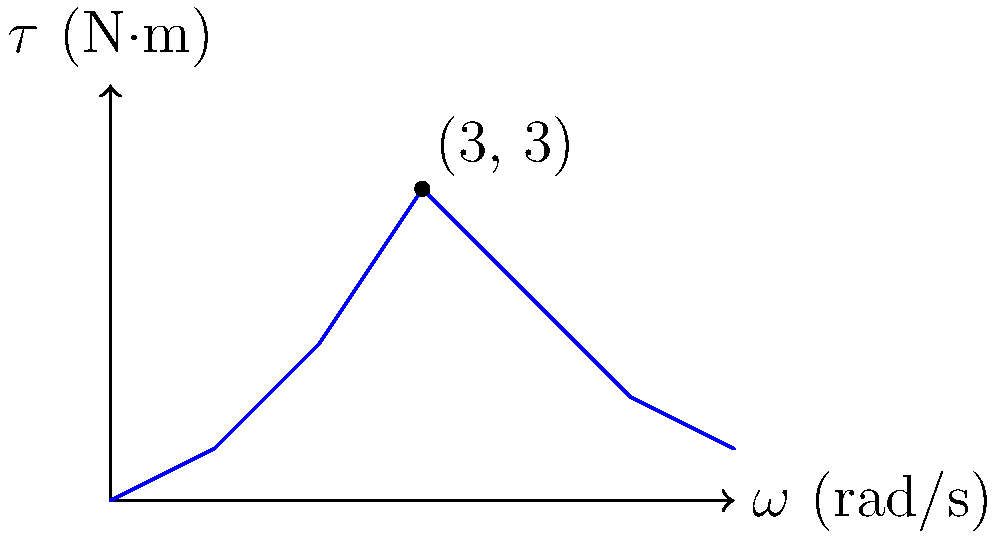A rotating shaft experiences a varying torque ($\tau$) over time, as shown in the graph. The shaft has a moment of inertia of 2 kg·m². At t = 3 seconds, the torque reaches its maximum value of 3 N·m. Calculate the angular acceleration ($\alpha$) of the shaft at this instant. To solve this problem, we'll use the rotational form of Newton's Second Law:

$$\tau = I\alpha$$

Where:
- $\tau$ is the torque
- $I$ is the moment of inertia
- $\alpha$ is the angular acceleration

We are given:
- $\tau = 3$ N·m (at t = 3 seconds)
- $I = 2$ kg·m²

Step 1: Rearrange the equation to solve for $\alpha$:
$$\alpha = \frac{\tau}{I}$$

Step 2: Substitute the known values:
$$\alpha = \frac{3 \text{ N·m}}{2 \text{ kg·m²}}$$

Step 3: Calculate the result:
$$\alpha = 1.5 \text{ rad/s²}$$

Therefore, the angular acceleration of the shaft at t = 3 seconds is 1.5 rad/s².
Answer: 1.5 rad/s² 